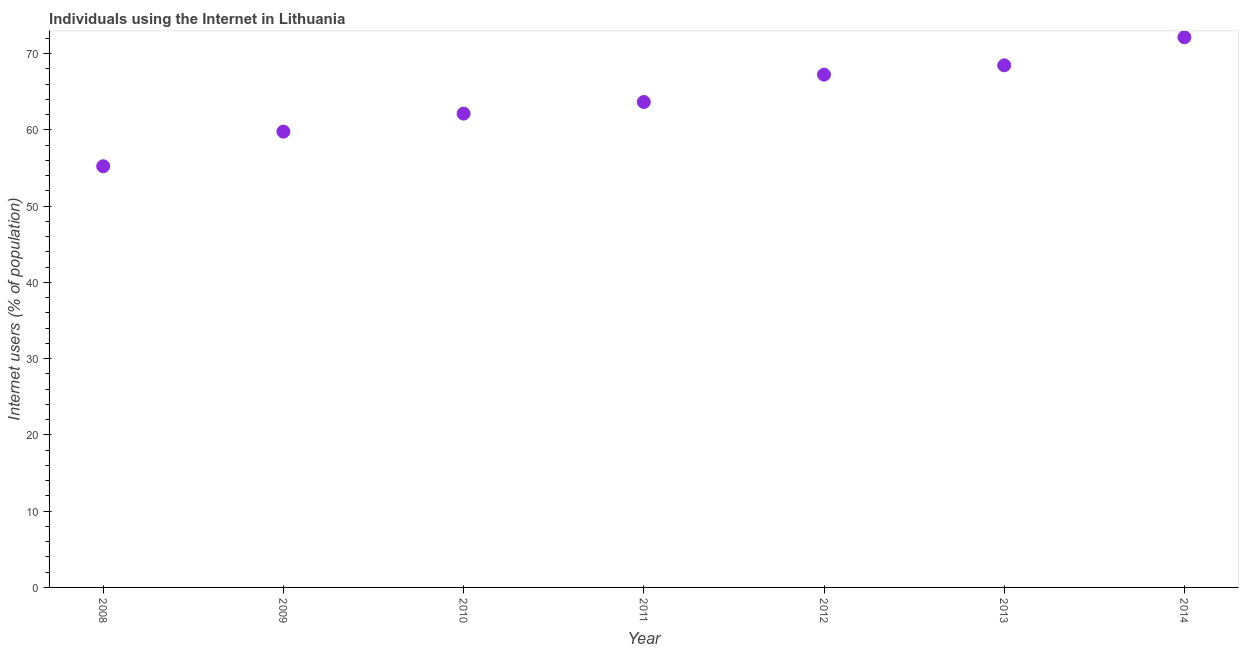What is the number of internet users in 2008?
Provide a short and direct response. 55.22. Across all years, what is the maximum number of internet users?
Give a very brief answer. 72.13. Across all years, what is the minimum number of internet users?
Provide a short and direct response. 55.22. In which year was the number of internet users maximum?
Your answer should be very brief. 2014. What is the sum of the number of internet users?
Give a very brief answer. 448.55. What is the difference between the number of internet users in 2008 and 2012?
Ensure brevity in your answer.  -12.01. What is the average number of internet users per year?
Give a very brief answer. 64.08. What is the median number of internet users?
Your answer should be very brief. 63.64. In how many years, is the number of internet users greater than 18 %?
Ensure brevity in your answer.  7. Do a majority of the years between 2013 and 2010 (inclusive) have number of internet users greater than 68 %?
Provide a short and direct response. Yes. What is the ratio of the number of internet users in 2009 to that in 2011?
Your response must be concise. 0.94. Is the number of internet users in 2013 less than that in 2014?
Keep it short and to the point. Yes. What is the difference between the highest and the second highest number of internet users?
Give a very brief answer. 3.68. Is the sum of the number of internet users in 2010 and 2012 greater than the maximum number of internet users across all years?
Make the answer very short. Yes. What is the difference between the highest and the lowest number of internet users?
Give a very brief answer. 16.91. What is the difference between two consecutive major ticks on the Y-axis?
Offer a very short reply. 10. Are the values on the major ticks of Y-axis written in scientific E-notation?
Offer a very short reply. No. Does the graph contain any zero values?
Offer a terse response. No. What is the title of the graph?
Keep it short and to the point. Individuals using the Internet in Lithuania. What is the label or title of the Y-axis?
Give a very brief answer. Internet users (% of population). What is the Internet users (% of population) in 2008?
Ensure brevity in your answer.  55.22. What is the Internet users (% of population) in 2009?
Your answer should be very brief. 59.76. What is the Internet users (% of population) in 2010?
Offer a terse response. 62.12. What is the Internet users (% of population) in 2011?
Your answer should be compact. 63.64. What is the Internet users (% of population) in 2012?
Ensure brevity in your answer.  67.23. What is the Internet users (% of population) in 2013?
Offer a terse response. 68.45. What is the Internet users (% of population) in 2014?
Your response must be concise. 72.13. What is the difference between the Internet users (% of population) in 2008 and 2009?
Make the answer very short. -4.54. What is the difference between the Internet users (% of population) in 2008 and 2010?
Keep it short and to the point. -6.9. What is the difference between the Internet users (% of population) in 2008 and 2011?
Your answer should be very brief. -8.42. What is the difference between the Internet users (% of population) in 2008 and 2012?
Your answer should be very brief. -12.01. What is the difference between the Internet users (% of population) in 2008 and 2013?
Give a very brief answer. -13.23. What is the difference between the Internet users (% of population) in 2008 and 2014?
Keep it short and to the point. -16.91. What is the difference between the Internet users (% of population) in 2009 and 2010?
Offer a very short reply. -2.36. What is the difference between the Internet users (% of population) in 2009 and 2011?
Your response must be concise. -3.88. What is the difference between the Internet users (% of population) in 2009 and 2012?
Provide a succinct answer. -7.47. What is the difference between the Internet users (% of population) in 2009 and 2013?
Your answer should be very brief. -8.69. What is the difference between the Internet users (% of population) in 2009 and 2014?
Offer a very short reply. -12.37. What is the difference between the Internet users (% of population) in 2010 and 2011?
Ensure brevity in your answer.  -1.52. What is the difference between the Internet users (% of population) in 2010 and 2012?
Provide a succinct answer. -5.11. What is the difference between the Internet users (% of population) in 2010 and 2013?
Ensure brevity in your answer.  -6.33. What is the difference between the Internet users (% of population) in 2010 and 2014?
Provide a succinct answer. -10.01. What is the difference between the Internet users (% of population) in 2011 and 2012?
Your answer should be compact. -3.59. What is the difference between the Internet users (% of population) in 2011 and 2013?
Your response must be concise. -4.81. What is the difference between the Internet users (% of population) in 2011 and 2014?
Your response must be concise. -8.49. What is the difference between the Internet users (% of population) in 2012 and 2013?
Give a very brief answer. -1.22. What is the difference between the Internet users (% of population) in 2012 and 2014?
Offer a terse response. -4.9. What is the difference between the Internet users (% of population) in 2013 and 2014?
Provide a succinct answer. -3.68. What is the ratio of the Internet users (% of population) in 2008 to that in 2009?
Give a very brief answer. 0.92. What is the ratio of the Internet users (% of population) in 2008 to that in 2010?
Provide a short and direct response. 0.89. What is the ratio of the Internet users (% of population) in 2008 to that in 2011?
Offer a very short reply. 0.87. What is the ratio of the Internet users (% of population) in 2008 to that in 2012?
Keep it short and to the point. 0.82. What is the ratio of the Internet users (% of population) in 2008 to that in 2013?
Provide a succinct answer. 0.81. What is the ratio of the Internet users (% of population) in 2008 to that in 2014?
Provide a short and direct response. 0.77. What is the ratio of the Internet users (% of population) in 2009 to that in 2011?
Offer a very short reply. 0.94. What is the ratio of the Internet users (% of population) in 2009 to that in 2012?
Offer a very short reply. 0.89. What is the ratio of the Internet users (% of population) in 2009 to that in 2013?
Offer a terse response. 0.87. What is the ratio of the Internet users (% of population) in 2009 to that in 2014?
Offer a very short reply. 0.83. What is the ratio of the Internet users (% of population) in 2010 to that in 2011?
Provide a short and direct response. 0.98. What is the ratio of the Internet users (% of population) in 2010 to that in 2012?
Offer a terse response. 0.92. What is the ratio of the Internet users (% of population) in 2010 to that in 2013?
Offer a terse response. 0.91. What is the ratio of the Internet users (% of population) in 2010 to that in 2014?
Your response must be concise. 0.86. What is the ratio of the Internet users (% of population) in 2011 to that in 2012?
Ensure brevity in your answer.  0.95. What is the ratio of the Internet users (% of population) in 2011 to that in 2013?
Offer a terse response. 0.93. What is the ratio of the Internet users (% of population) in 2011 to that in 2014?
Ensure brevity in your answer.  0.88. What is the ratio of the Internet users (% of population) in 2012 to that in 2013?
Offer a very short reply. 0.98. What is the ratio of the Internet users (% of population) in 2012 to that in 2014?
Provide a short and direct response. 0.93. What is the ratio of the Internet users (% of population) in 2013 to that in 2014?
Your answer should be very brief. 0.95. 